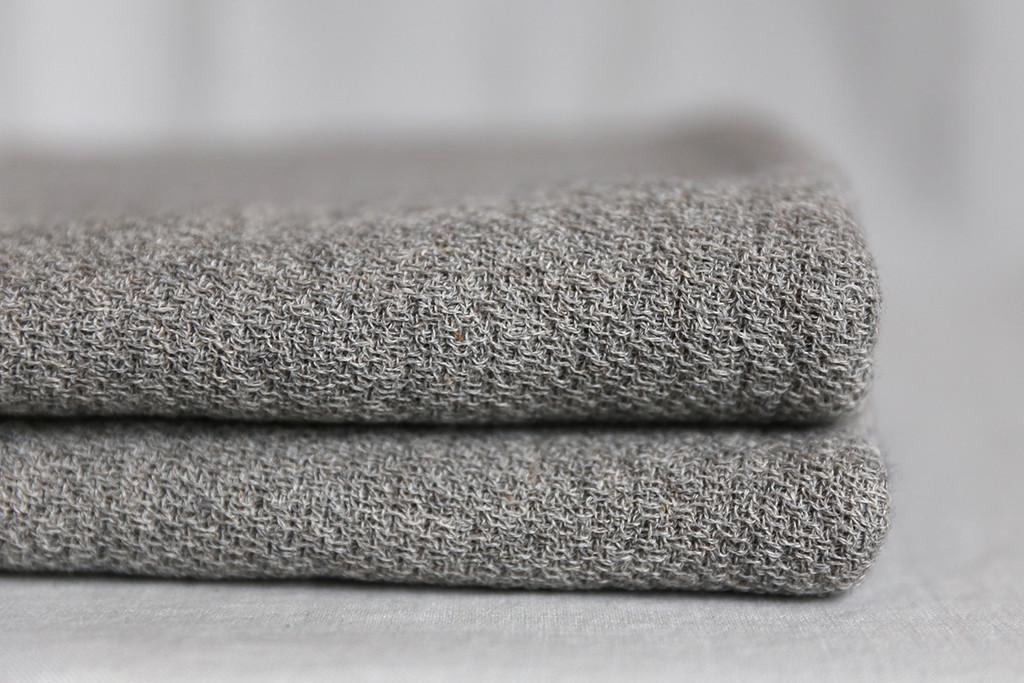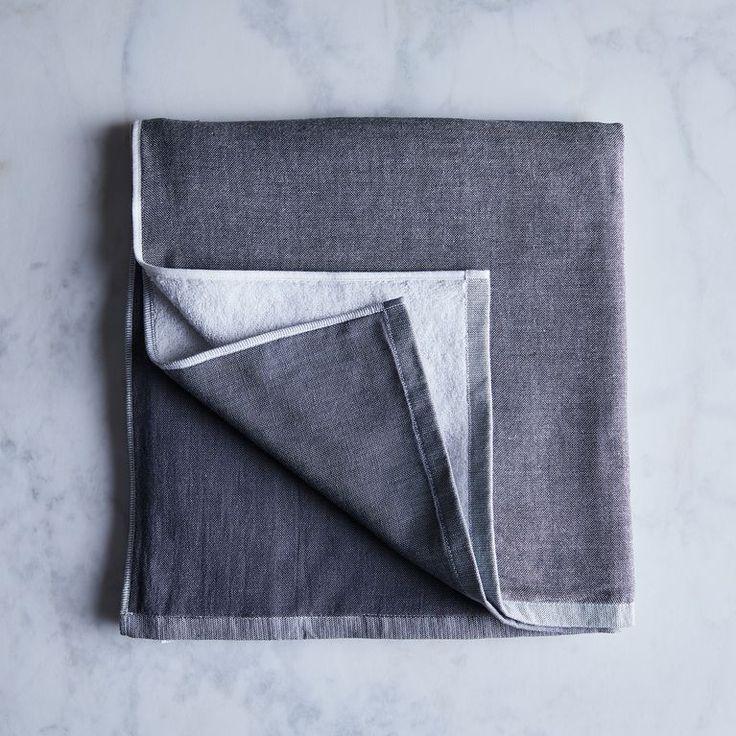The first image is the image on the left, the second image is the image on the right. For the images displayed, is the sentence "One of the images shows a folded gray item with a distinctive weave." factually correct? Answer yes or no. Yes. 